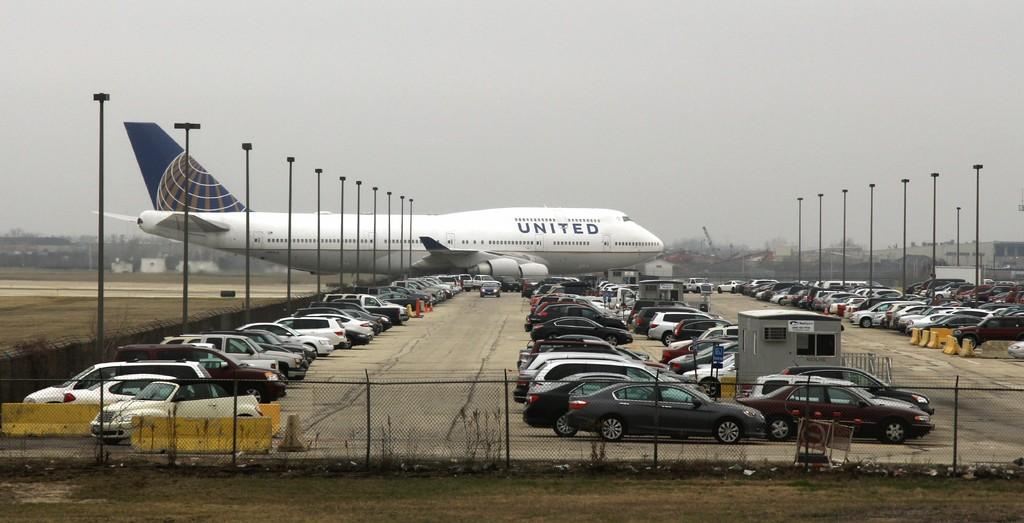<image>
Provide a brief description of the given image. a plane that has the word 'united' written on the side of it 